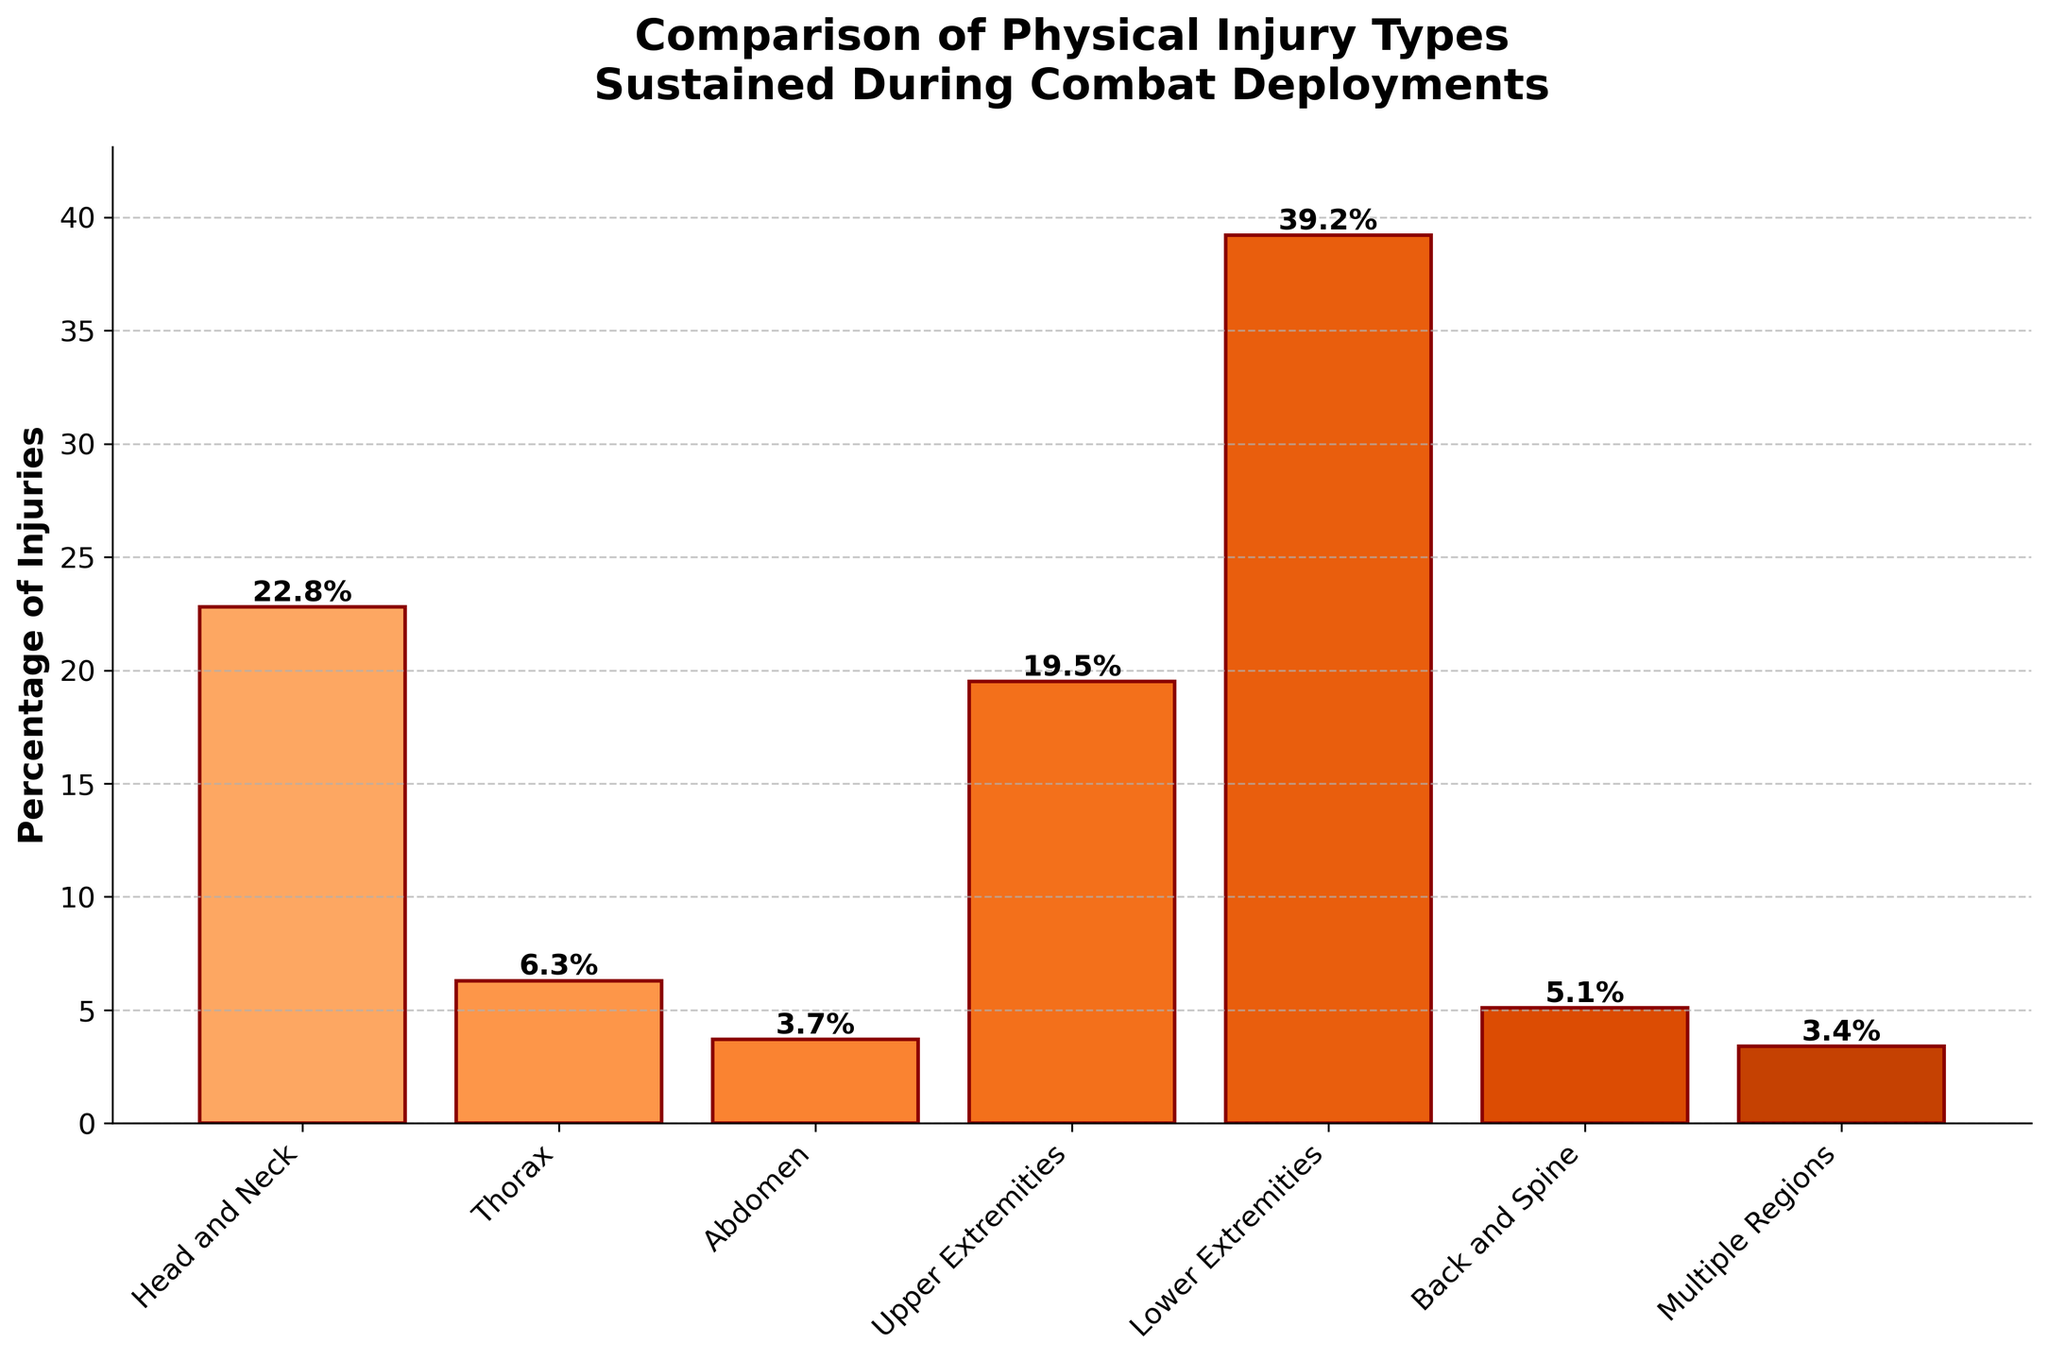Which body region sustained the highest percentage of injuries? The bar representing the 'Lower Extremities' region is the tallest, indicating the highest percentage of injuries.
Answer: Lower Extremities What is the combined percentage of injuries for the Upper and Lower Extremities? Add the percentages for Upper Extremities (19.5) and Lower Extremities (39.2). The sum is 19.5 + 39.2 = 58.7.
Answer: 58.7 Which body region has fewer injuries, the Thorax or the Back and Spine? Compare the heights of the bars for 'Thorax' (6.3) and 'Back and Spine' (5.1). The 'Back and Spine' bar is shorter.
Answer: Back and Spine How much greater is the percentage of injuries for the Head and Neck compared to the Abdomen? Subtract the percentage of injuries for 'Abdomen' (3.7) from 'Head and Neck' (22.8). The difference is 22.8 - 3.7 = 19.1.
Answer: 19.1 Are the percentages of injuries for the Back and Spine higher or lower than those for the Multiple Regions? Compare the percentages: 'Back and Spine' (5.1) versus 'Multiple Regions' (3.4). The 'Back and Spine' percentage is higher.
Answer: Higher In terms of injury percentages, place the Upper Extremities and Thorax in order from the highest to the lowest. Compare the percentages: Upper Extremities (19.5) and Thorax (6.3). The order from highest to lowest is Upper Extremities > Thorax.
Answer: Upper Extremities, Thorax Which body region has the third highest percentage of injuries? Arrange the percentages in descending order: Lower Extremities (39.2), Head and Neck (22.8), and Upper Extremities (19.5). The third highest is Upper Extremities (19.5).
Answer: Upper Extremities What is the average percentage of injuries across all body regions? Calculate the average by summing all percentages: 22.8 + 6.3 + 3.7 + 19.5 + 39.2 + 5.1 + 3.4 = 100. Then, divide by the number of regions (7): 100 / 7 ≈ 14.3.
Answer: 14.3 What is the difference in the percentage of injuries between regions with the highest and the lowest percentages? Subtract the lowest percentage (Multiple Regions at 3.4) from the highest percentage (Lower Extremities at 39.2). The difference is 39.2 - 3.4 = 35.8.
Answer: 35.8 